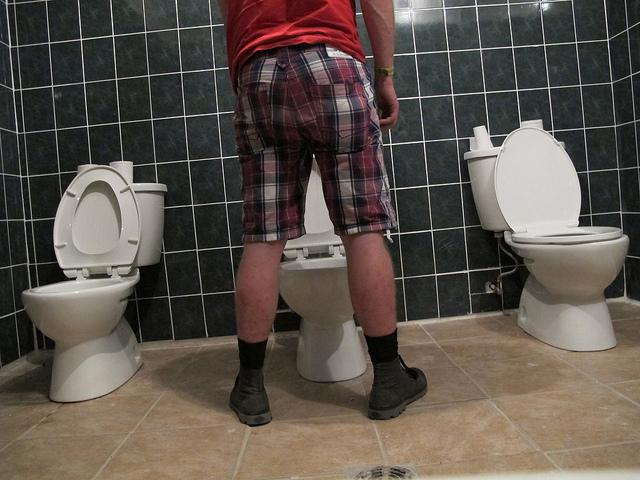Which room is this?

Choices:
A) ball
B) kitchen
C) men's restroom
D) ladies room men's restroom 